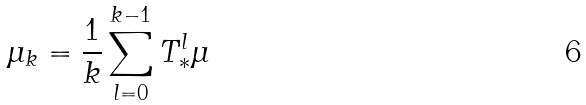Convert formula to latex. <formula><loc_0><loc_0><loc_500><loc_500>\mu _ { k } = \frac { 1 } { k } \sum _ { l = 0 } ^ { k - 1 } T _ { \ast } ^ { l } \mu</formula> 